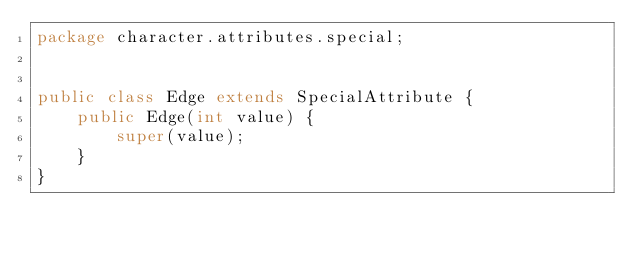<code> <loc_0><loc_0><loc_500><loc_500><_Java_>package character.attributes.special;


public class Edge extends SpecialAttribute {
    public Edge(int value) {
        super(value);
    }
}
</code> 